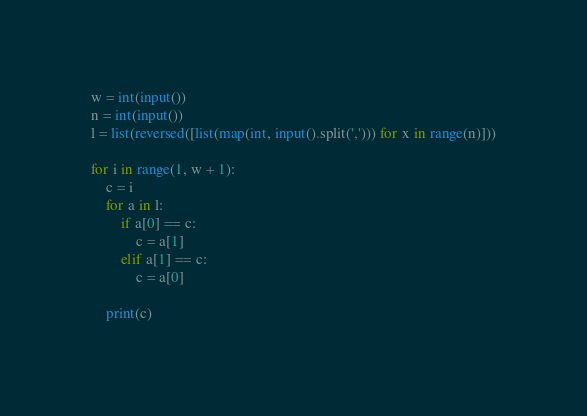<code> <loc_0><loc_0><loc_500><loc_500><_Python_>w = int(input())
n = int(input())
l = list(reversed([list(map(int, input().split(','))) for x in range(n)]))

for i in range(1, w + 1):
    c = i
    for a in l:
        if a[0] == c:
            c = a[1]
        elif a[1] == c:
            c = a[0]

    print(c)</code> 